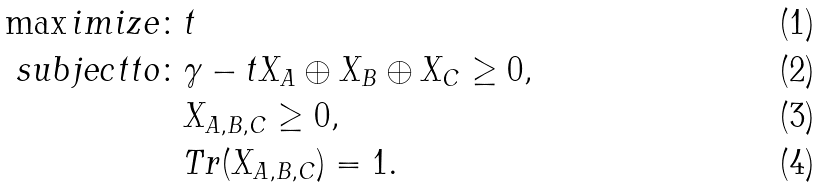<formula> <loc_0><loc_0><loc_500><loc_500>\max i m i z e \colon & t \\ s u b j e c t t o \colon & \gamma - t X _ { A } \oplus X _ { B } \oplus X _ { C } \geq 0 , \\ & X _ { A , B , C } \geq 0 , \\ & T r ( X _ { A , B , C } ) = 1 .</formula> 